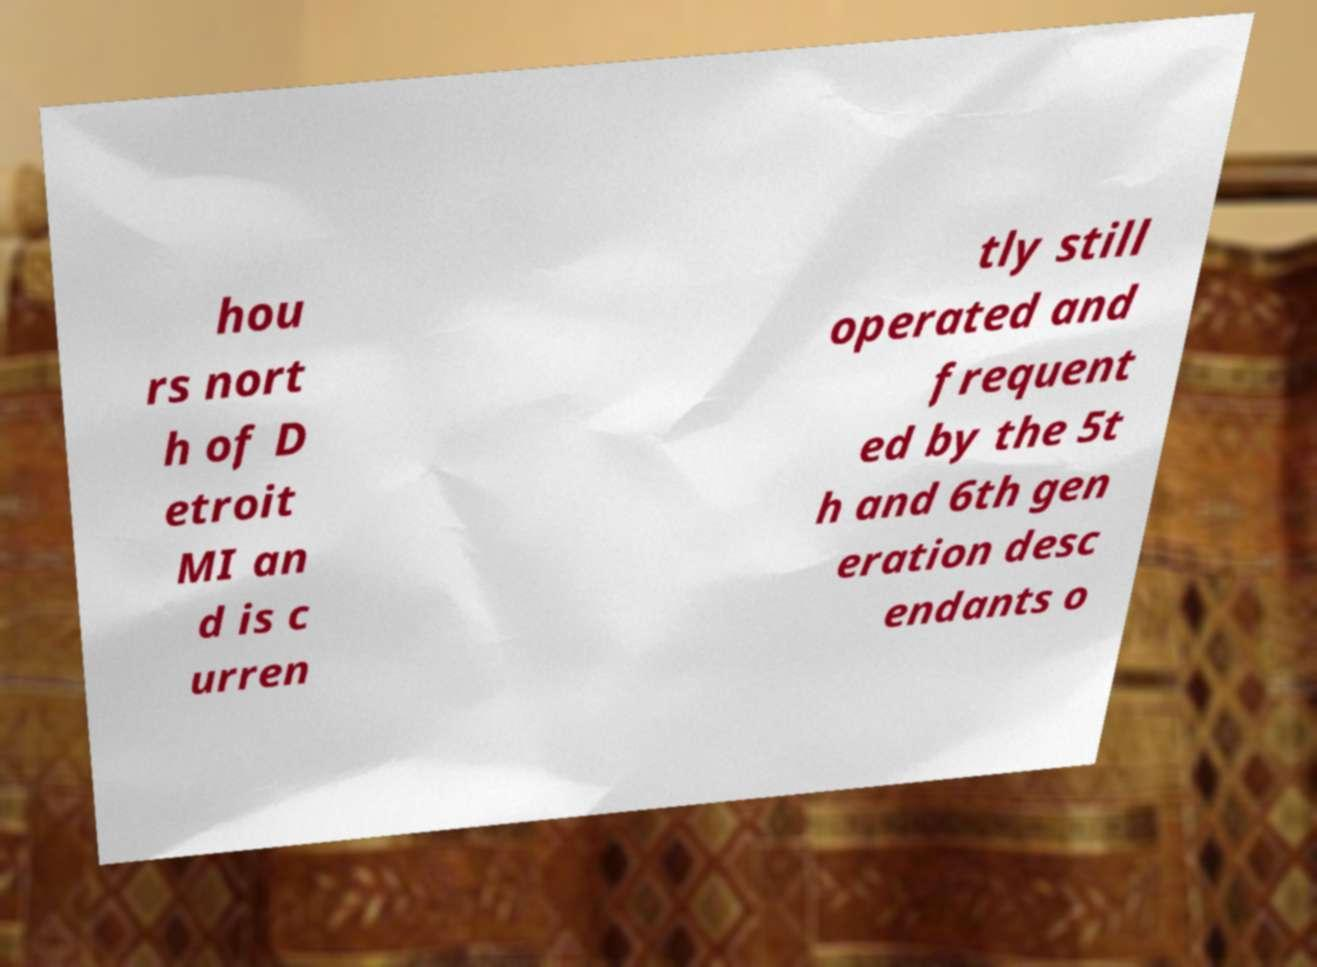Could you assist in decoding the text presented in this image and type it out clearly? hou rs nort h of D etroit MI an d is c urren tly still operated and frequent ed by the 5t h and 6th gen eration desc endants o 